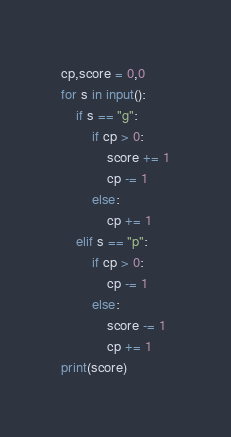<code> <loc_0><loc_0><loc_500><loc_500><_Python_>cp,score = 0,0
for s in input():
    if s == "g":
        if cp > 0:
            score += 1
            cp -= 1
        else:
            cp += 1
    elif s == "p":
        if cp > 0:
            cp -= 1
        else:
            score -= 1
            cp += 1
print(score)</code> 